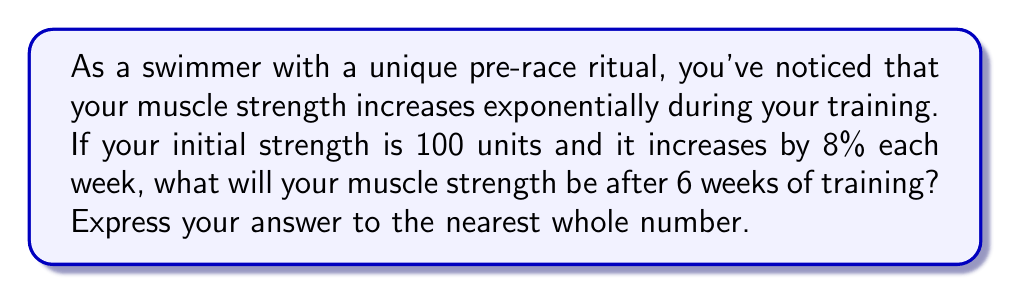Help me with this question. Let's approach this step-by-step:

1) The initial strength is 100 units.
2) The growth rate is 8% per week, which means the strength is multiplied by 1.08 each week.
3) We need to calculate this for 6 weeks.

This scenario follows the exponential growth formula:

$$ A = P(1 + r)^t $$

Where:
$A$ = Final amount
$P$ = Initial amount (principal)
$r$ = Growth rate (as a decimal)
$t$ = Time periods

In our case:
$P = 100$
$r = 0.08$
$t = 6$

Let's plug these into our formula:

$$ A = 100(1 + 0.08)^6 $$
$$ A = 100(1.08)^6 $$

Now, let's calculate:

$$ A = 100 * 1.5869 $$
$$ A = 158.69 $$

Rounding to the nearest whole number:

$$ A ≈ 159 $$

This means after 6 weeks of training, your muscle strength will be approximately 159 units.
Answer: 159 units 